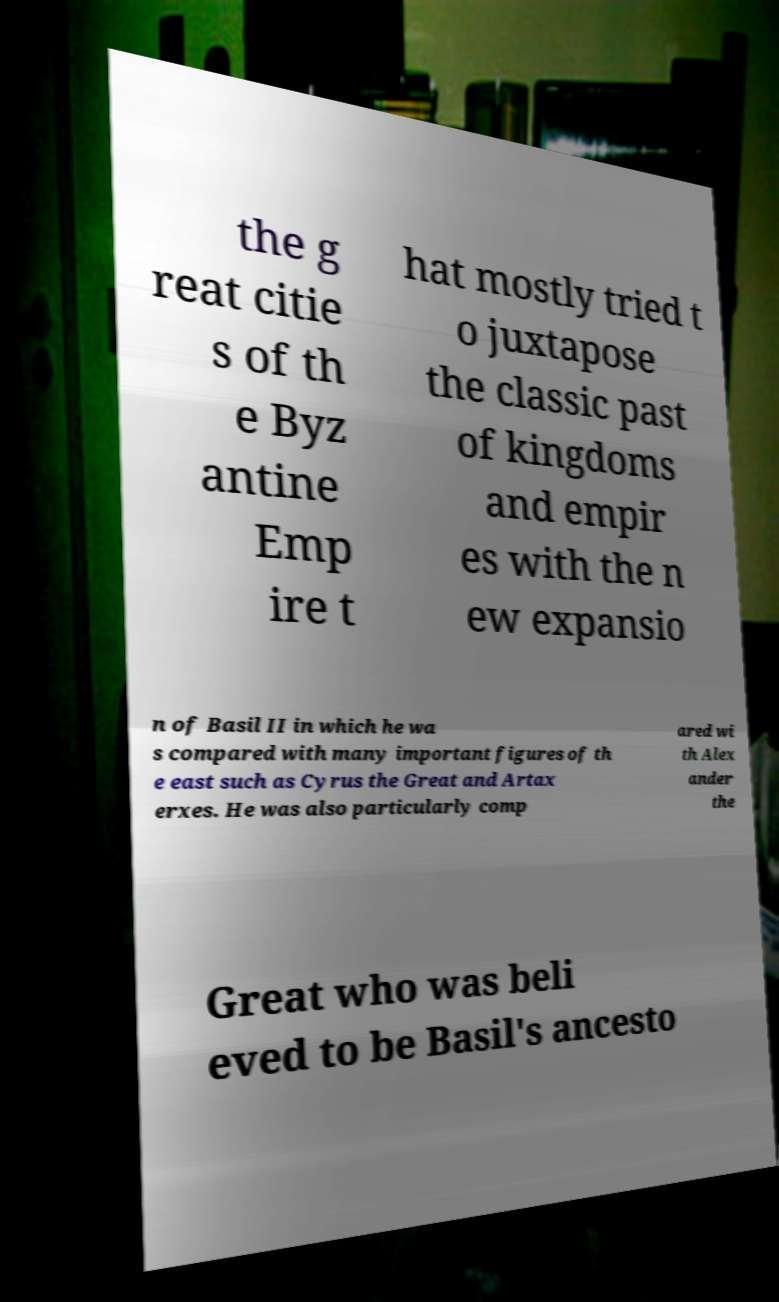Please read and relay the text visible in this image. What does it say? the g reat citie s of th e Byz antine Emp ire t hat mostly tried t o juxtapose the classic past of kingdoms and empir es with the n ew expansio n of Basil II in which he wa s compared with many important figures of th e east such as Cyrus the Great and Artax erxes. He was also particularly comp ared wi th Alex ander the Great who was beli eved to be Basil's ancesto 